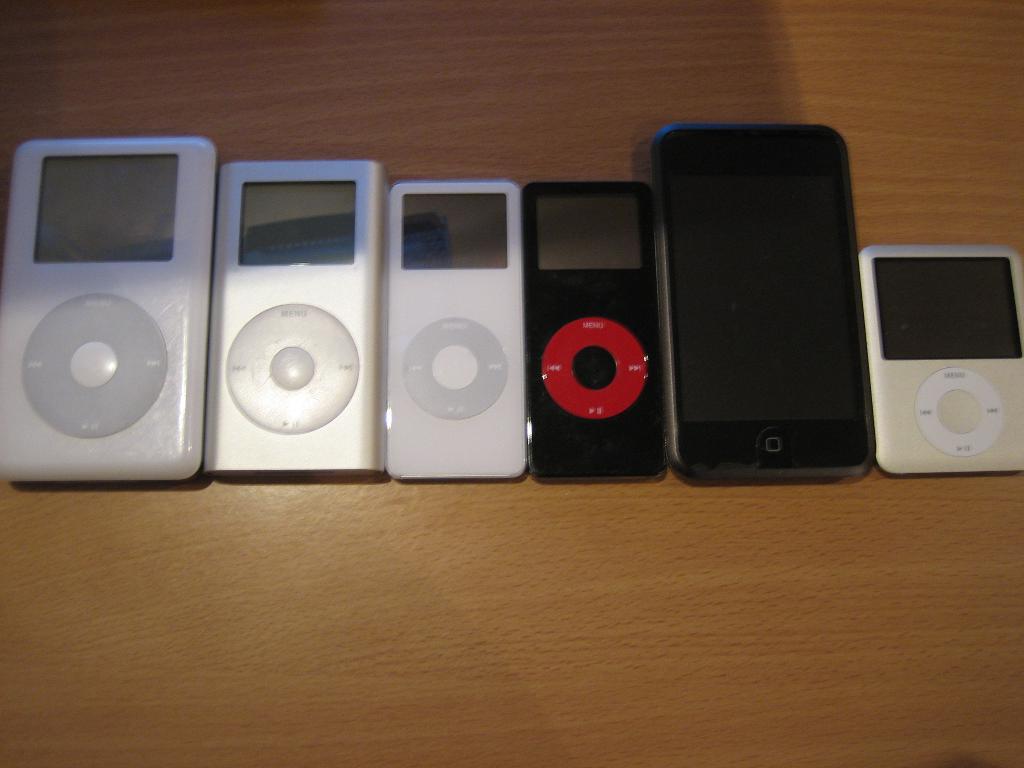Could you give a brief overview of what you see in this image? In this picture we can see electronic gadgets placed on a table. 